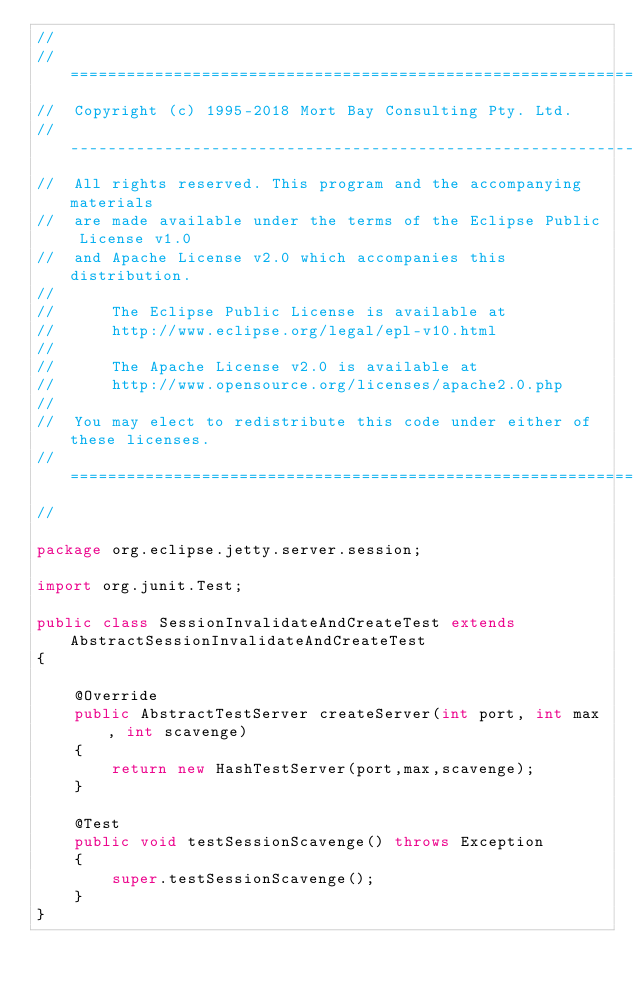<code> <loc_0><loc_0><loc_500><loc_500><_Java_>//
//  ========================================================================
//  Copyright (c) 1995-2018 Mort Bay Consulting Pty. Ltd.
//  ------------------------------------------------------------------------
//  All rights reserved. This program and the accompanying materials
//  are made available under the terms of the Eclipse Public License v1.0
//  and Apache License v2.0 which accompanies this distribution.
//
//      The Eclipse Public License is available at
//      http://www.eclipse.org/legal/epl-v10.html
//
//      The Apache License v2.0 is available at
//      http://www.opensource.org/licenses/apache2.0.php
//
//  You may elect to redistribute this code under either of these licenses.
//  ========================================================================
//

package org.eclipse.jetty.server.session;

import org.junit.Test;

public class SessionInvalidateAndCreateTest extends AbstractSessionInvalidateAndCreateTest
{

    @Override
    public AbstractTestServer createServer(int port, int max, int scavenge)
    {
        return new HashTestServer(port,max,scavenge);
    }
    
    @Test
    public void testSessionScavenge() throws Exception
    {
        super.testSessionScavenge();
    }
}
</code> 